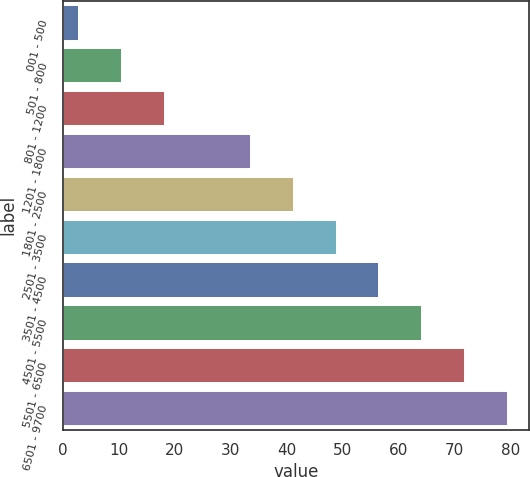Convert chart to OTSL. <chart><loc_0><loc_0><loc_500><loc_500><bar_chart><fcel>001 - 500<fcel>501 - 800<fcel>801 - 1200<fcel>1201 - 1800<fcel>1801 - 2500<fcel>2501 - 3500<fcel>3501 - 4500<fcel>4501 - 5500<fcel>5501 - 6500<fcel>6501 - 9700<nl><fcel>2.76<fcel>10.42<fcel>18.08<fcel>33.4<fcel>41.06<fcel>48.72<fcel>56.38<fcel>64.04<fcel>71.7<fcel>79.39<nl></chart> 